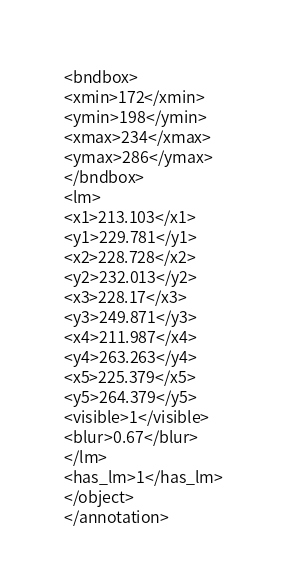<code> <loc_0><loc_0><loc_500><loc_500><_XML_><bndbox>
<xmin>172</xmin>
<ymin>198</ymin>
<xmax>234</xmax>
<ymax>286</ymax>
</bndbox>
<lm>
<x1>213.103</x1>
<y1>229.781</y1>
<x2>228.728</x2>
<y2>232.013</y2>
<x3>228.17</x3>
<y3>249.871</y3>
<x4>211.987</x4>
<y4>263.263</y4>
<x5>225.379</x5>
<y5>264.379</y5>
<visible>1</visible>
<blur>0.67</blur>
</lm>
<has_lm>1</has_lm>
</object>
</annotation>
</code> 